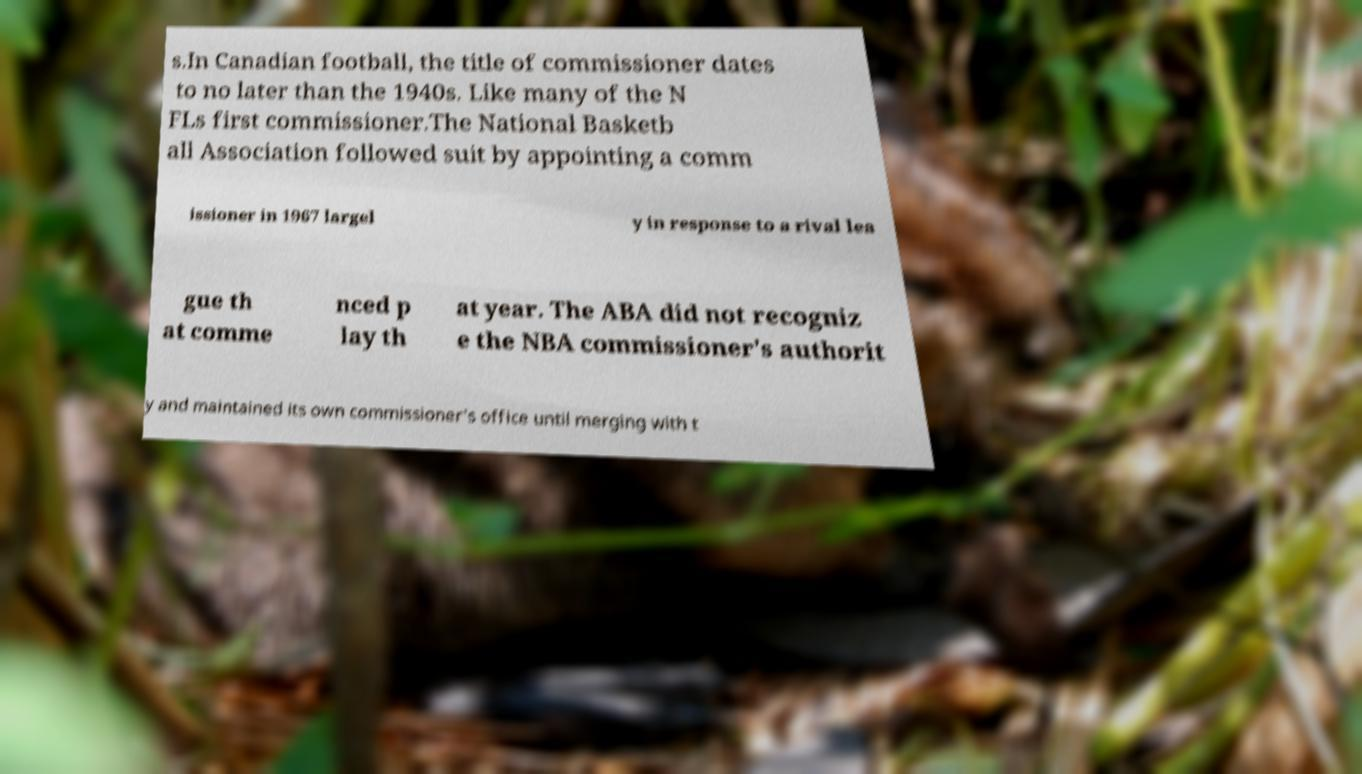For documentation purposes, I need the text within this image transcribed. Could you provide that? s.In Canadian football, the title of commissioner dates to no later than the 1940s. Like many of the N FLs first commissioner.The National Basketb all Association followed suit by appointing a comm issioner in 1967 largel y in response to a rival lea gue th at comme nced p lay th at year. The ABA did not recogniz e the NBA commissioner's authorit y and maintained its own commissioner's office until merging with t 